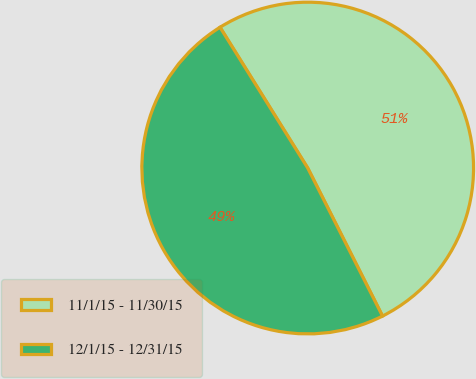Convert chart. <chart><loc_0><loc_0><loc_500><loc_500><pie_chart><fcel>11/1/15 - 11/30/15<fcel>12/1/15 - 12/31/15<nl><fcel>51.42%<fcel>48.58%<nl></chart> 